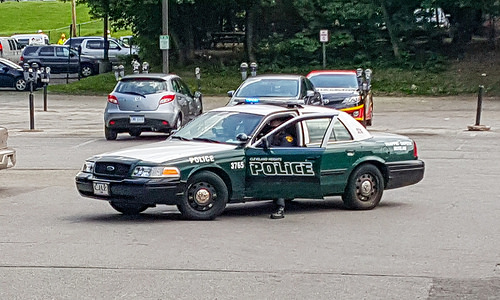<image>
Is there a car above the road? No. The car is not positioned above the road. The vertical arrangement shows a different relationship. 